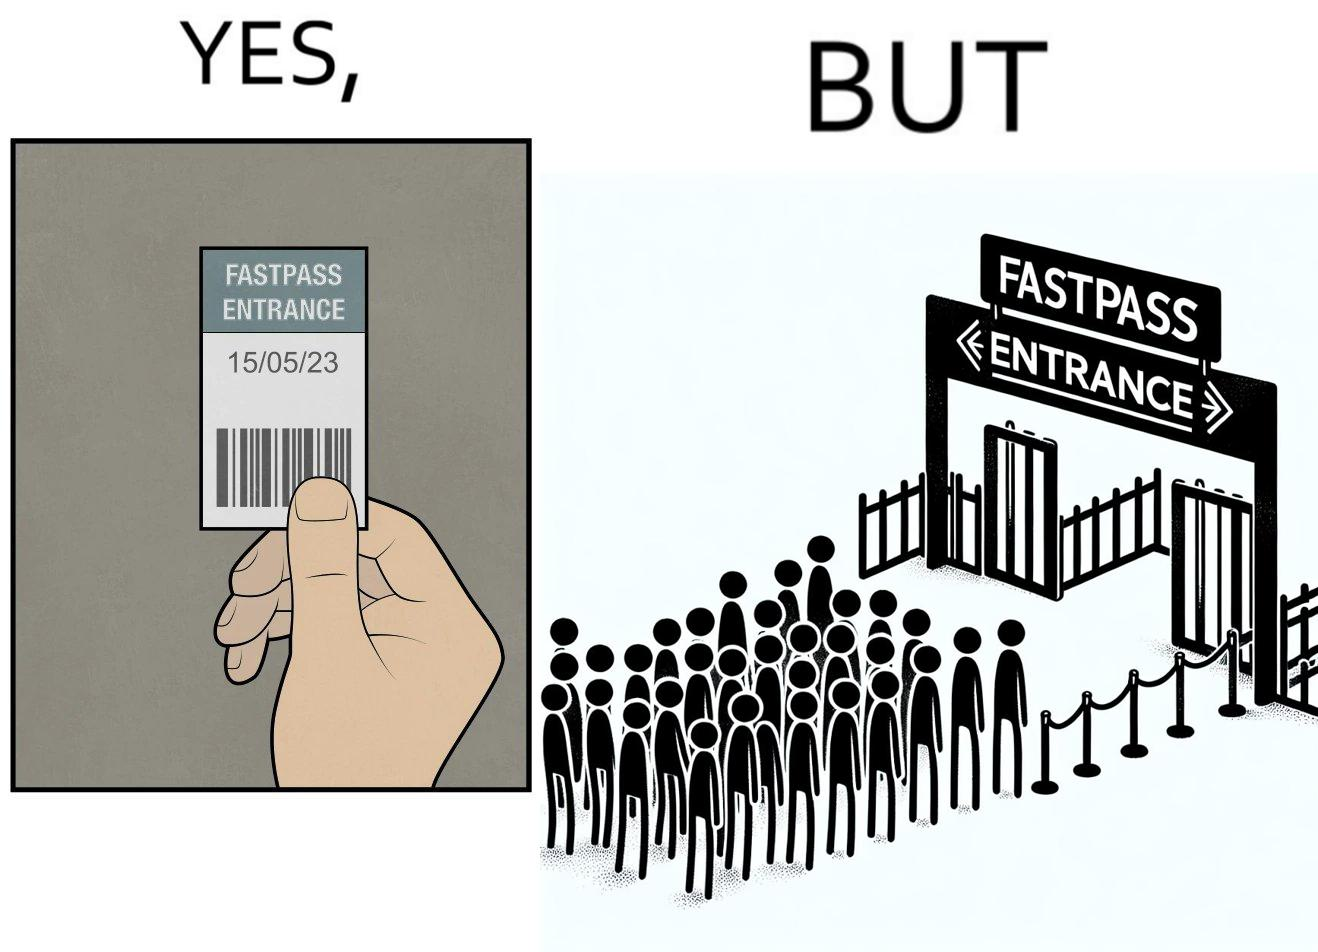Describe what you see in this image. The image is ironic, because fast pass entrance was meant for people to pass the gate fast but as more no. of people bought the pass due to which the queue has become longer and it becomes slow and time consuming 